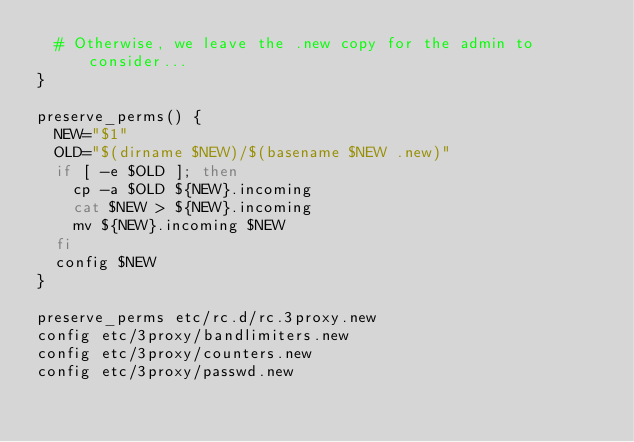Convert code to text. <code><loc_0><loc_0><loc_500><loc_500><_Bash_>  # Otherwise, we leave the .new copy for the admin to consider...
}

preserve_perms() {
  NEW="$1"
  OLD="$(dirname $NEW)/$(basename $NEW .new)"
  if [ -e $OLD ]; then
    cp -a $OLD ${NEW}.incoming
    cat $NEW > ${NEW}.incoming
    mv ${NEW}.incoming $NEW
  fi
  config $NEW
}

preserve_perms etc/rc.d/rc.3proxy.new
config etc/3proxy/bandlimiters.new
config etc/3proxy/counters.new
config etc/3proxy/passwd.new
</code> 